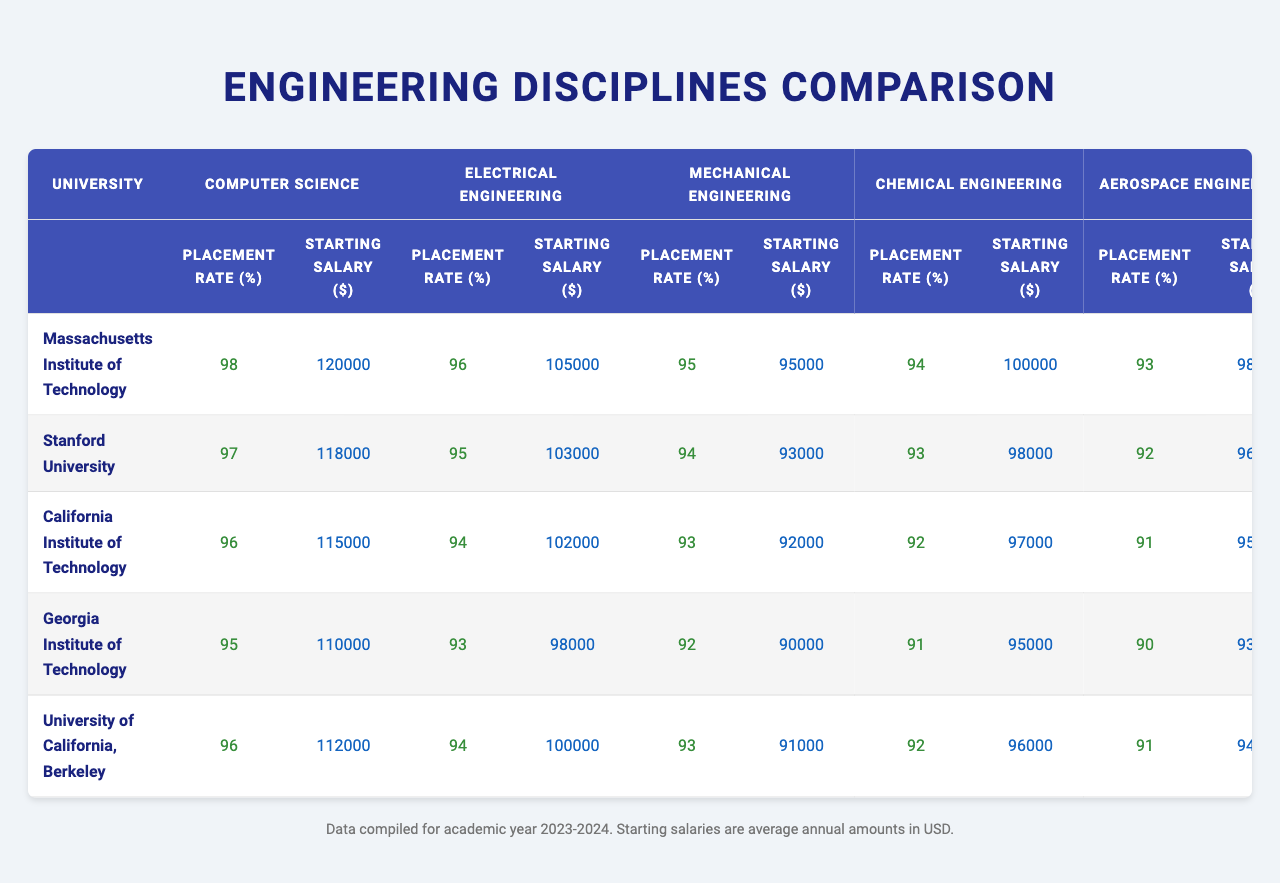What is the highest placement rate among the engineering disciplines at the Massachusetts Institute of Technology? The table indicates that the Computer Science discipline at the Massachusetts Institute of Technology has a placement rate of 98%, which is the highest among all listed disciplines at that university.
Answer: 98% Which university has the lowest starting salary for Mechanical Engineering? By examining the table, the lowest starting salary for Mechanical Engineering is found at California Institute of Technology, where it is $92,000.
Answer: $92,000 What is the average placement rate for Chemical Engineering across all universities? The placement rates for Chemical Engineering are 94%, 93%, 92%, 91%, and 92% for MIT, Stanford, Caltech, Georgia Tech, and UC Berkeley respectively. The average is calculated as: (94 + 93 + 92 + 91 + 92) / 5 = 92.2%.
Answer: 92.2% Which engineering discipline has the highest starting salary at Stanford University? The table shows that Computer Science has the highest starting salary at Stanford University, with a starting salary of $118,000.
Answer: $118,000 Is the placement rate for Electrical Engineering at Georgia Institute of Technology higher than that at University of California, Berkeley? The table shows that Georgia Institute of Technology has a placement rate of 93% for Electrical Engineering, while University of California, Berkeley has a placement rate of 94%. Thus, it is false that Georgia Institute of Technology's rate is higher.
Answer: No What is the difference in starting salary between Computer Science at MIT and Electrical Engineering at Stanford? The starting salary for Computer Science at MIT is $120,000 while Electrical Engineering at Stanford has a starting salary of $103,000. The difference is $120,000 - $103,000 = $17,000.
Answer: $17,000 Which university has the highest overall placement rate across all engineering disciplines? By reviewing the table, the highest overall placement rate is seen at the Massachusetts Institute of Technology with 98%, 96%, 95%, 94%, and 93% across its disciplines. This equates to an average of (98 + 96 + 95 + 94 + 93) / 5 = 95.2%. No other university surpasses this average.
Answer: Massachusetts Institute of Technology What is the median starting salary for Aerospace Engineering across the provided universities? The starting salaries for Aerospace Engineering are $98,000 (MIT), $96,000 (Stanford), $95,000 (Caltech), $93,000 (Georgia Tech), and $94,000 (UC Berkeley). When arranged in order: $93,000, $94,000, $95,000, $96,000, $98,000, the median is the middle value, which is $95,000.
Answer: $95,000 Which discipline has a higher placement rate at UC Berkeley: Mechanical Engineering or Aerospace Engineering? The placement rate for Mechanical Engineering at UC Berkeley is 93%, while for Aerospace Engineering it is 91%. Therefore, Mechanical Engineering has the higher placement rate.
Answer: Mechanical Engineering How much higher is the starting salary for Computer Science at the best-performing university compared to the worst-performing university for that discipline? The best-performing university for Computer Science is Massachusetts Institute of Technology at $120,000, whereas the lowest performance for Computer Science is at Georgia Institute of Technology with $110,000. However, the difference between $120,000 and $110,000 is $10,000.
Answer: $10,000 What is the combined placement rate for Electrical Engineering at California Institute of Technology and Georgia Institute of Technology? The placement rates for Electrical Engineering are 94% for California Institute of Technology and 93% for Georgia Institute of Technology. The combined placement rate is 94 + 93 = 187%.
Answer: 187% 